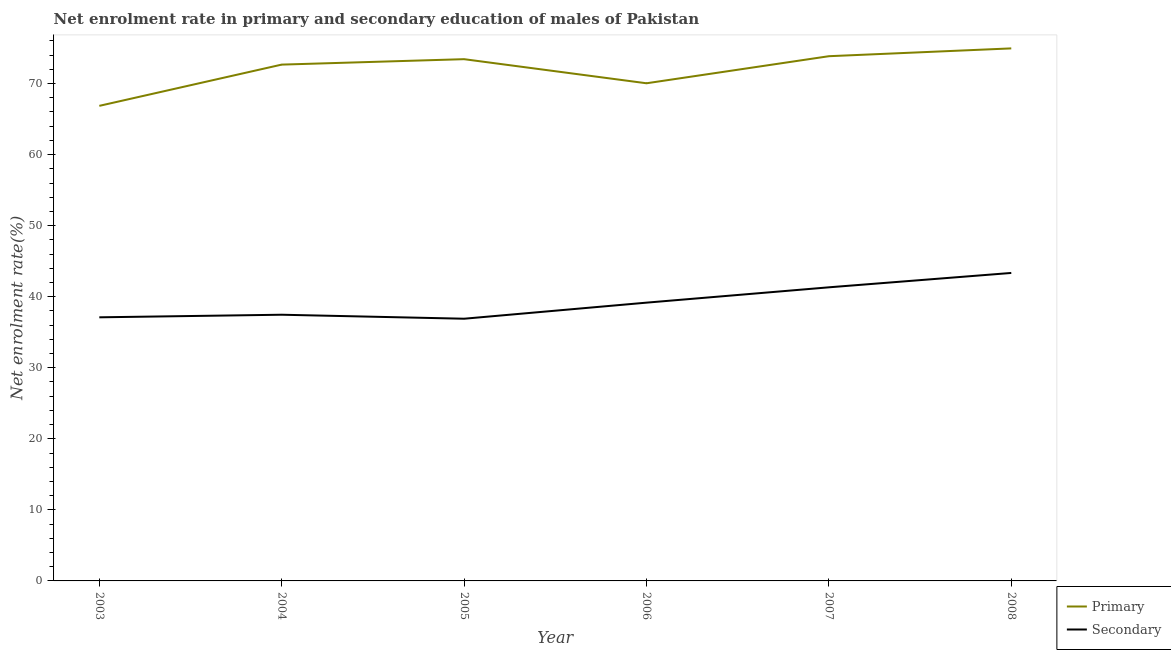Does the line corresponding to enrollment rate in secondary education intersect with the line corresponding to enrollment rate in primary education?
Offer a very short reply. No. What is the enrollment rate in primary education in 2007?
Your answer should be compact. 73.85. Across all years, what is the maximum enrollment rate in primary education?
Offer a terse response. 74.95. Across all years, what is the minimum enrollment rate in primary education?
Your answer should be compact. 66.86. In which year was the enrollment rate in secondary education minimum?
Ensure brevity in your answer.  2005. What is the total enrollment rate in secondary education in the graph?
Your answer should be compact. 235.31. What is the difference between the enrollment rate in secondary education in 2003 and that in 2006?
Provide a short and direct response. -2.06. What is the difference between the enrollment rate in secondary education in 2004 and the enrollment rate in primary education in 2003?
Offer a terse response. -29.4. What is the average enrollment rate in secondary education per year?
Your answer should be very brief. 39.22. In the year 2008, what is the difference between the enrollment rate in primary education and enrollment rate in secondary education?
Provide a short and direct response. 31.6. In how many years, is the enrollment rate in secondary education greater than 42 %?
Your answer should be very brief. 1. What is the ratio of the enrollment rate in primary education in 2005 to that in 2006?
Your response must be concise. 1.05. What is the difference between the highest and the second highest enrollment rate in primary education?
Offer a terse response. 1.1. What is the difference between the highest and the lowest enrollment rate in primary education?
Offer a very short reply. 8.09. In how many years, is the enrollment rate in primary education greater than the average enrollment rate in primary education taken over all years?
Provide a short and direct response. 4. Does the enrollment rate in secondary education monotonically increase over the years?
Your response must be concise. No. Is the enrollment rate in secondary education strictly less than the enrollment rate in primary education over the years?
Offer a very short reply. Yes. How many years are there in the graph?
Provide a succinct answer. 6. What is the difference between two consecutive major ticks on the Y-axis?
Give a very brief answer. 10. Where does the legend appear in the graph?
Give a very brief answer. Bottom right. What is the title of the graph?
Keep it short and to the point. Net enrolment rate in primary and secondary education of males of Pakistan. Does "Services" appear as one of the legend labels in the graph?
Provide a short and direct response. No. What is the label or title of the X-axis?
Make the answer very short. Year. What is the label or title of the Y-axis?
Make the answer very short. Net enrolment rate(%). What is the Net enrolment rate(%) of Primary in 2003?
Make the answer very short. 66.86. What is the Net enrolment rate(%) of Secondary in 2003?
Your answer should be very brief. 37.1. What is the Net enrolment rate(%) in Primary in 2004?
Offer a very short reply. 72.67. What is the Net enrolment rate(%) of Secondary in 2004?
Keep it short and to the point. 37.47. What is the Net enrolment rate(%) in Primary in 2005?
Offer a very short reply. 73.43. What is the Net enrolment rate(%) of Secondary in 2005?
Keep it short and to the point. 36.9. What is the Net enrolment rate(%) in Primary in 2006?
Ensure brevity in your answer.  70.04. What is the Net enrolment rate(%) of Secondary in 2006?
Your answer should be compact. 39.17. What is the Net enrolment rate(%) in Primary in 2007?
Keep it short and to the point. 73.85. What is the Net enrolment rate(%) in Secondary in 2007?
Give a very brief answer. 41.32. What is the Net enrolment rate(%) in Primary in 2008?
Your answer should be compact. 74.95. What is the Net enrolment rate(%) of Secondary in 2008?
Provide a succinct answer. 43.35. Across all years, what is the maximum Net enrolment rate(%) of Primary?
Make the answer very short. 74.95. Across all years, what is the maximum Net enrolment rate(%) of Secondary?
Keep it short and to the point. 43.35. Across all years, what is the minimum Net enrolment rate(%) in Primary?
Your answer should be compact. 66.86. Across all years, what is the minimum Net enrolment rate(%) of Secondary?
Your answer should be very brief. 36.9. What is the total Net enrolment rate(%) in Primary in the graph?
Provide a short and direct response. 431.81. What is the total Net enrolment rate(%) of Secondary in the graph?
Your answer should be compact. 235.31. What is the difference between the Net enrolment rate(%) in Primary in 2003 and that in 2004?
Your answer should be very brief. -5.81. What is the difference between the Net enrolment rate(%) of Secondary in 2003 and that in 2004?
Your response must be concise. -0.36. What is the difference between the Net enrolment rate(%) of Primary in 2003 and that in 2005?
Offer a terse response. -6.57. What is the difference between the Net enrolment rate(%) of Secondary in 2003 and that in 2005?
Provide a succinct answer. 0.2. What is the difference between the Net enrolment rate(%) in Primary in 2003 and that in 2006?
Provide a short and direct response. -3.18. What is the difference between the Net enrolment rate(%) of Secondary in 2003 and that in 2006?
Ensure brevity in your answer.  -2.06. What is the difference between the Net enrolment rate(%) in Primary in 2003 and that in 2007?
Keep it short and to the point. -6.99. What is the difference between the Net enrolment rate(%) in Secondary in 2003 and that in 2007?
Your answer should be compact. -4.22. What is the difference between the Net enrolment rate(%) of Primary in 2003 and that in 2008?
Offer a terse response. -8.09. What is the difference between the Net enrolment rate(%) in Secondary in 2003 and that in 2008?
Provide a short and direct response. -6.24. What is the difference between the Net enrolment rate(%) of Primary in 2004 and that in 2005?
Make the answer very short. -0.76. What is the difference between the Net enrolment rate(%) in Secondary in 2004 and that in 2005?
Your answer should be compact. 0.56. What is the difference between the Net enrolment rate(%) of Primary in 2004 and that in 2006?
Provide a short and direct response. 2.63. What is the difference between the Net enrolment rate(%) of Secondary in 2004 and that in 2006?
Your answer should be compact. -1.7. What is the difference between the Net enrolment rate(%) of Primary in 2004 and that in 2007?
Give a very brief answer. -1.18. What is the difference between the Net enrolment rate(%) in Secondary in 2004 and that in 2007?
Keep it short and to the point. -3.86. What is the difference between the Net enrolment rate(%) in Primary in 2004 and that in 2008?
Your answer should be very brief. -2.28. What is the difference between the Net enrolment rate(%) in Secondary in 2004 and that in 2008?
Your answer should be compact. -5.88. What is the difference between the Net enrolment rate(%) of Primary in 2005 and that in 2006?
Ensure brevity in your answer.  3.39. What is the difference between the Net enrolment rate(%) of Secondary in 2005 and that in 2006?
Your answer should be very brief. -2.26. What is the difference between the Net enrolment rate(%) in Primary in 2005 and that in 2007?
Your answer should be very brief. -0.42. What is the difference between the Net enrolment rate(%) in Secondary in 2005 and that in 2007?
Your answer should be very brief. -4.42. What is the difference between the Net enrolment rate(%) in Primary in 2005 and that in 2008?
Keep it short and to the point. -1.52. What is the difference between the Net enrolment rate(%) in Secondary in 2005 and that in 2008?
Your answer should be very brief. -6.44. What is the difference between the Net enrolment rate(%) of Primary in 2006 and that in 2007?
Offer a terse response. -3.81. What is the difference between the Net enrolment rate(%) in Secondary in 2006 and that in 2007?
Keep it short and to the point. -2.16. What is the difference between the Net enrolment rate(%) of Primary in 2006 and that in 2008?
Your response must be concise. -4.91. What is the difference between the Net enrolment rate(%) of Secondary in 2006 and that in 2008?
Make the answer very short. -4.18. What is the difference between the Net enrolment rate(%) in Primary in 2007 and that in 2008?
Your answer should be compact. -1.1. What is the difference between the Net enrolment rate(%) of Secondary in 2007 and that in 2008?
Offer a terse response. -2.02. What is the difference between the Net enrolment rate(%) in Primary in 2003 and the Net enrolment rate(%) in Secondary in 2004?
Ensure brevity in your answer.  29.4. What is the difference between the Net enrolment rate(%) of Primary in 2003 and the Net enrolment rate(%) of Secondary in 2005?
Offer a very short reply. 29.96. What is the difference between the Net enrolment rate(%) of Primary in 2003 and the Net enrolment rate(%) of Secondary in 2006?
Offer a terse response. 27.7. What is the difference between the Net enrolment rate(%) of Primary in 2003 and the Net enrolment rate(%) of Secondary in 2007?
Make the answer very short. 25.54. What is the difference between the Net enrolment rate(%) of Primary in 2003 and the Net enrolment rate(%) of Secondary in 2008?
Provide a succinct answer. 23.52. What is the difference between the Net enrolment rate(%) in Primary in 2004 and the Net enrolment rate(%) in Secondary in 2005?
Provide a succinct answer. 35.77. What is the difference between the Net enrolment rate(%) in Primary in 2004 and the Net enrolment rate(%) in Secondary in 2006?
Give a very brief answer. 33.5. What is the difference between the Net enrolment rate(%) of Primary in 2004 and the Net enrolment rate(%) of Secondary in 2007?
Make the answer very short. 31.35. What is the difference between the Net enrolment rate(%) in Primary in 2004 and the Net enrolment rate(%) in Secondary in 2008?
Your response must be concise. 29.32. What is the difference between the Net enrolment rate(%) of Primary in 2005 and the Net enrolment rate(%) of Secondary in 2006?
Your response must be concise. 34.27. What is the difference between the Net enrolment rate(%) of Primary in 2005 and the Net enrolment rate(%) of Secondary in 2007?
Your answer should be compact. 32.11. What is the difference between the Net enrolment rate(%) in Primary in 2005 and the Net enrolment rate(%) in Secondary in 2008?
Ensure brevity in your answer.  30.09. What is the difference between the Net enrolment rate(%) in Primary in 2006 and the Net enrolment rate(%) in Secondary in 2007?
Your response must be concise. 28.72. What is the difference between the Net enrolment rate(%) in Primary in 2006 and the Net enrolment rate(%) in Secondary in 2008?
Provide a succinct answer. 26.69. What is the difference between the Net enrolment rate(%) in Primary in 2007 and the Net enrolment rate(%) in Secondary in 2008?
Make the answer very short. 30.5. What is the average Net enrolment rate(%) of Primary per year?
Provide a short and direct response. 71.97. What is the average Net enrolment rate(%) in Secondary per year?
Offer a terse response. 39.22. In the year 2003, what is the difference between the Net enrolment rate(%) in Primary and Net enrolment rate(%) in Secondary?
Make the answer very short. 29.76. In the year 2004, what is the difference between the Net enrolment rate(%) of Primary and Net enrolment rate(%) of Secondary?
Your response must be concise. 35.2. In the year 2005, what is the difference between the Net enrolment rate(%) in Primary and Net enrolment rate(%) in Secondary?
Give a very brief answer. 36.53. In the year 2006, what is the difference between the Net enrolment rate(%) in Primary and Net enrolment rate(%) in Secondary?
Keep it short and to the point. 30.88. In the year 2007, what is the difference between the Net enrolment rate(%) in Primary and Net enrolment rate(%) in Secondary?
Provide a short and direct response. 32.53. In the year 2008, what is the difference between the Net enrolment rate(%) in Primary and Net enrolment rate(%) in Secondary?
Offer a terse response. 31.6. What is the ratio of the Net enrolment rate(%) in Primary in 2003 to that in 2004?
Keep it short and to the point. 0.92. What is the ratio of the Net enrolment rate(%) in Secondary in 2003 to that in 2004?
Provide a succinct answer. 0.99. What is the ratio of the Net enrolment rate(%) of Primary in 2003 to that in 2005?
Offer a very short reply. 0.91. What is the ratio of the Net enrolment rate(%) in Secondary in 2003 to that in 2005?
Provide a succinct answer. 1.01. What is the ratio of the Net enrolment rate(%) of Primary in 2003 to that in 2006?
Provide a succinct answer. 0.95. What is the ratio of the Net enrolment rate(%) in Secondary in 2003 to that in 2006?
Keep it short and to the point. 0.95. What is the ratio of the Net enrolment rate(%) in Primary in 2003 to that in 2007?
Your answer should be compact. 0.91. What is the ratio of the Net enrolment rate(%) in Secondary in 2003 to that in 2007?
Provide a short and direct response. 0.9. What is the ratio of the Net enrolment rate(%) in Primary in 2003 to that in 2008?
Offer a terse response. 0.89. What is the ratio of the Net enrolment rate(%) of Secondary in 2003 to that in 2008?
Keep it short and to the point. 0.86. What is the ratio of the Net enrolment rate(%) of Primary in 2004 to that in 2005?
Keep it short and to the point. 0.99. What is the ratio of the Net enrolment rate(%) of Secondary in 2004 to that in 2005?
Provide a short and direct response. 1.02. What is the ratio of the Net enrolment rate(%) in Primary in 2004 to that in 2006?
Your answer should be compact. 1.04. What is the ratio of the Net enrolment rate(%) of Secondary in 2004 to that in 2006?
Your response must be concise. 0.96. What is the ratio of the Net enrolment rate(%) of Secondary in 2004 to that in 2007?
Your answer should be very brief. 0.91. What is the ratio of the Net enrolment rate(%) in Primary in 2004 to that in 2008?
Your answer should be compact. 0.97. What is the ratio of the Net enrolment rate(%) in Secondary in 2004 to that in 2008?
Make the answer very short. 0.86. What is the ratio of the Net enrolment rate(%) of Primary in 2005 to that in 2006?
Give a very brief answer. 1.05. What is the ratio of the Net enrolment rate(%) of Secondary in 2005 to that in 2006?
Make the answer very short. 0.94. What is the ratio of the Net enrolment rate(%) of Primary in 2005 to that in 2007?
Your answer should be compact. 0.99. What is the ratio of the Net enrolment rate(%) in Secondary in 2005 to that in 2007?
Provide a short and direct response. 0.89. What is the ratio of the Net enrolment rate(%) of Primary in 2005 to that in 2008?
Your answer should be very brief. 0.98. What is the ratio of the Net enrolment rate(%) of Secondary in 2005 to that in 2008?
Provide a short and direct response. 0.85. What is the ratio of the Net enrolment rate(%) of Primary in 2006 to that in 2007?
Provide a succinct answer. 0.95. What is the ratio of the Net enrolment rate(%) of Secondary in 2006 to that in 2007?
Your answer should be very brief. 0.95. What is the ratio of the Net enrolment rate(%) in Primary in 2006 to that in 2008?
Provide a succinct answer. 0.93. What is the ratio of the Net enrolment rate(%) of Secondary in 2006 to that in 2008?
Make the answer very short. 0.9. What is the ratio of the Net enrolment rate(%) in Secondary in 2007 to that in 2008?
Your response must be concise. 0.95. What is the difference between the highest and the second highest Net enrolment rate(%) of Primary?
Your answer should be compact. 1.1. What is the difference between the highest and the second highest Net enrolment rate(%) in Secondary?
Offer a very short reply. 2.02. What is the difference between the highest and the lowest Net enrolment rate(%) of Primary?
Provide a succinct answer. 8.09. What is the difference between the highest and the lowest Net enrolment rate(%) of Secondary?
Your answer should be compact. 6.44. 